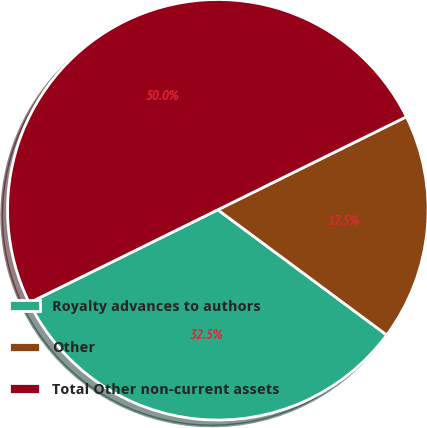Convert chart to OTSL. <chart><loc_0><loc_0><loc_500><loc_500><pie_chart><fcel>Royalty advances to authors<fcel>Other<fcel>Total Other non-current assets<nl><fcel>32.55%<fcel>17.45%<fcel>50.0%<nl></chart> 